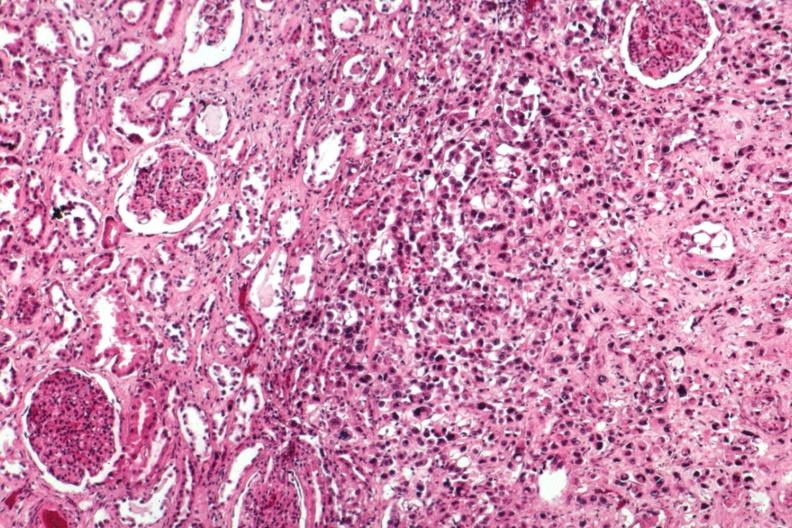s metastatic carcinoma breast present?
Answer the question using a single word or phrase. Yes 